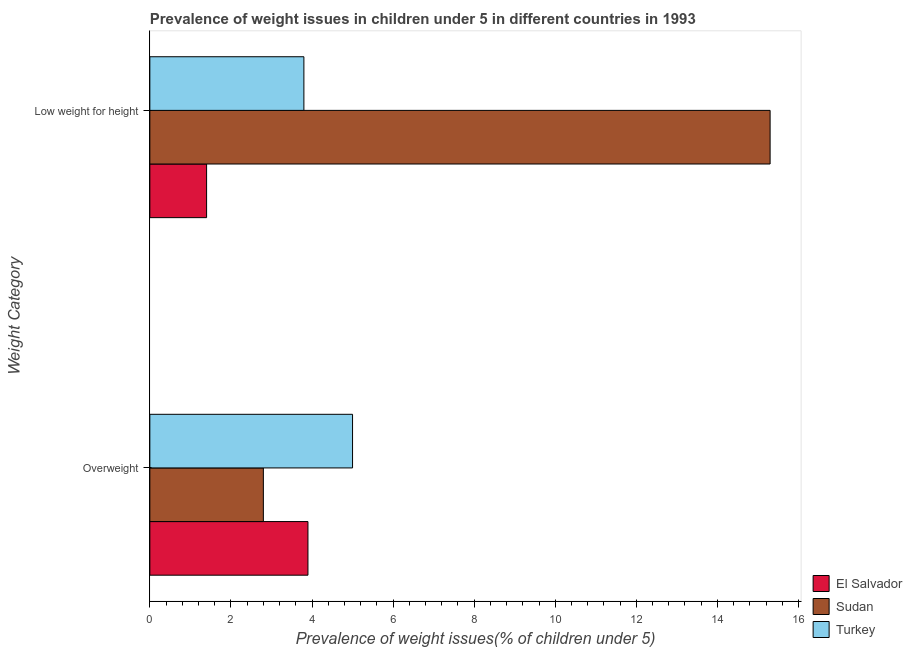What is the label of the 2nd group of bars from the top?
Provide a succinct answer. Overweight. What is the percentage of overweight children in Turkey?
Your response must be concise. 5. Across all countries, what is the maximum percentage of underweight children?
Offer a terse response. 15.3. Across all countries, what is the minimum percentage of underweight children?
Make the answer very short. 1.4. In which country was the percentage of underweight children minimum?
Ensure brevity in your answer.  El Salvador. What is the total percentage of overweight children in the graph?
Offer a very short reply. 11.7. What is the difference between the percentage of overweight children in El Salvador and that in Turkey?
Your response must be concise. -1.1. What is the average percentage of underweight children per country?
Give a very brief answer. 6.83. What is the difference between the percentage of underweight children and percentage of overweight children in Sudan?
Offer a very short reply. 12.5. In how many countries, is the percentage of overweight children greater than 3.2 %?
Make the answer very short. 2. What is the ratio of the percentage of overweight children in El Salvador to that in Turkey?
Offer a terse response. 0.78. What does the 3rd bar from the top in Overweight represents?
Make the answer very short. El Salvador. What does the 2nd bar from the bottom in Low weight for height represents?
Offer a very short reply. Sudan. How many bars are there?
Provide a short and direct response. 6. Are the values on the major ticks of X-axis written in scientific E-notation?
Offer a very short reply. No. How many legend labels are there?
Your response must be concise. 3. How are the legend labels stacked?
Offer a very short reply. Vertical. What is the title of the graph?
Give a very brief answer. Prevalence of weight issues in children under 5 in different countries in 1993. Does "St. Kitts and Nevis" appear as one of the legend labels in the graph?
Offer a terse response. No. What is the label or title of the X-axis?
Your answer should be compact. Prevalence of weight issues(% of children under 5). What is the label or title of the Y-axis?
Your answer should be very brief. Weight Category. What is the Prevalence of weight issues(% of children under 5) of El Salvador in Overweight?
Provide a succinct answer. 3.9. What is the Prevalence of weight issues(% of children under 5) in Sudan in Overweight?
Give a very brief answer. 2.8. What is the Prevalence of weight issues(% of children under 5) in Turkey in Overweight?
Give a very brief answer. 5. What is the Prevalence of weight issues(% of children under 5) of El Salvador in Low weight for height?
Provide a short and direct response. 1.4. What is the Prevalence of weight issues(% of children under 5) of Sudan in Low weight for height?
Provide a succinct answer. 15.3. What is the Prevalence of weight issues(% of children under 5) of Turkey in Low weight for height?
Provide a short and direct response. 3.8. Across all Weight Category, what is the maximum Prevalence of weight issues(% of children under 5) in El Salvador?
Offer a terse response. 3.9. Across all Weight Category, what is the maximum Prevalence of weight issues(% of children under 5) of Sudan?
Provide a short and direct response. 15.3. Across all Weight Category, what is the minimum Prevalence of weight issues(% of children under 5) in El Salvador?
Give a very brief answer. 1.4. Across all Weight Category, what is the minimum Prevalence of weight issues(% of children under 5) of Sudan?
Provide a succinct answer. 2.8. Across all Weight Category, what is the minimum Prevalence of weight issues(% of children under 5) of Turkey?
Your response must be concise. 3.8. What is the total Prevalence of weight issues(% of children under 5) in El Salvador in the graph?
Ensure brevity in your answer.  5.3. What is the total Prevalence of weight issues(% of children under 5) of Turkey in the graph?
Provide a short and direct response. 8.8. What is the difference between the Prevalence of weight issues(% of children under 5) in Sudan in Overweight and that in Low weight for height?
Your answer should be compact. -12.5. What is the difference between the Prevalence of weight issues(% of children under 5) in El Salvador in Overweight and the Prevalence of weight issues(% of children under 5) in Sudan in Low weight for height?
Your answer should be compact. -11.4. What is the difference between the Prevalence of weight issues(% of children under 5) of El Salvador in Overweight and the Prevalence of weight issues(% of children under 5) of Turkey in Low weight for height?
Offer a terse response. 0.1. What is the difference between the Prevalence of weight issues(% of children under 5) in Sudan in Overweight and the Prevalence of weight issues(% of children under 5) in Turkey in Low weight for height?
Provide a short and direct response. -1. What is the average Prevalence of weight issues(% of children under 5) in El Salvador per Weight Category?
Offer a very short reply. 2.65. What is the average Prevalence of weight issues(% of children under 5) in Sudan per Weight Category?
Make the answer very short. 9.05. What is the average Prevalence of weight issues(% of children under 5) in Turkey per Weight Category?
Your response must be concise. 4.4. What is the difference between the Prevalence of weight issues(% of children under 5) of Sudan and Prevalence of weight issues(% of children under 5) of Turkey in Overweight?
Ensure brevity in your answer.  -2.2. What is the difference between the Prevalence of weight issues(% of children under 5) in Sudan and Prevalence of weight issues(% of children under 5) in Turkey in Low weight for height?
Your answer should be compact. 11.5. What is the ratio of the Prevalence of weight issues(% of children under 5) in El Salvador in Overweight to that in Low weight for height?
Offer a terse response. 2.79. What is the ratio of the Prevalence of weight issues(% of children under 5) of Sudan in Overweight to that in Low weight for height?
Keep it short and to the point. 0.18. What is the ratio of the Prevalence of weight issues(% of children under 5) in Turkey in Overweight to that in Low weight for height?
Give a very brief answer. 1.32. What is the difference between the highest and the second highest Prevalence of weight issues(% of children under 5) of Sudan?
Ensure brevity in your answer.  12.5. What is the difference between the highest and the lowest Prevalence of weight issues(% of children under 5) in Sudan?
Give a very brief answer. 12.5. What is the difference between the highest and the lowest Prevalence of weight issues(% of children under 5) in Turkey?
Your response must be concise. 1.2. 